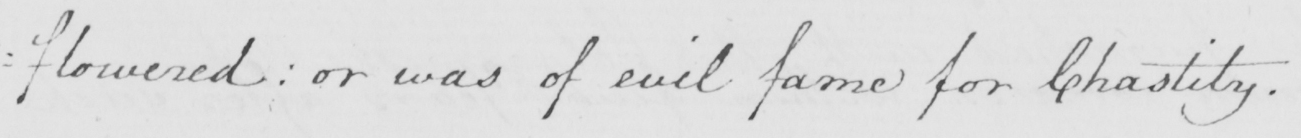Can you tell me what this handwritten text says? : flowered or was of evil fame for Chastity . 